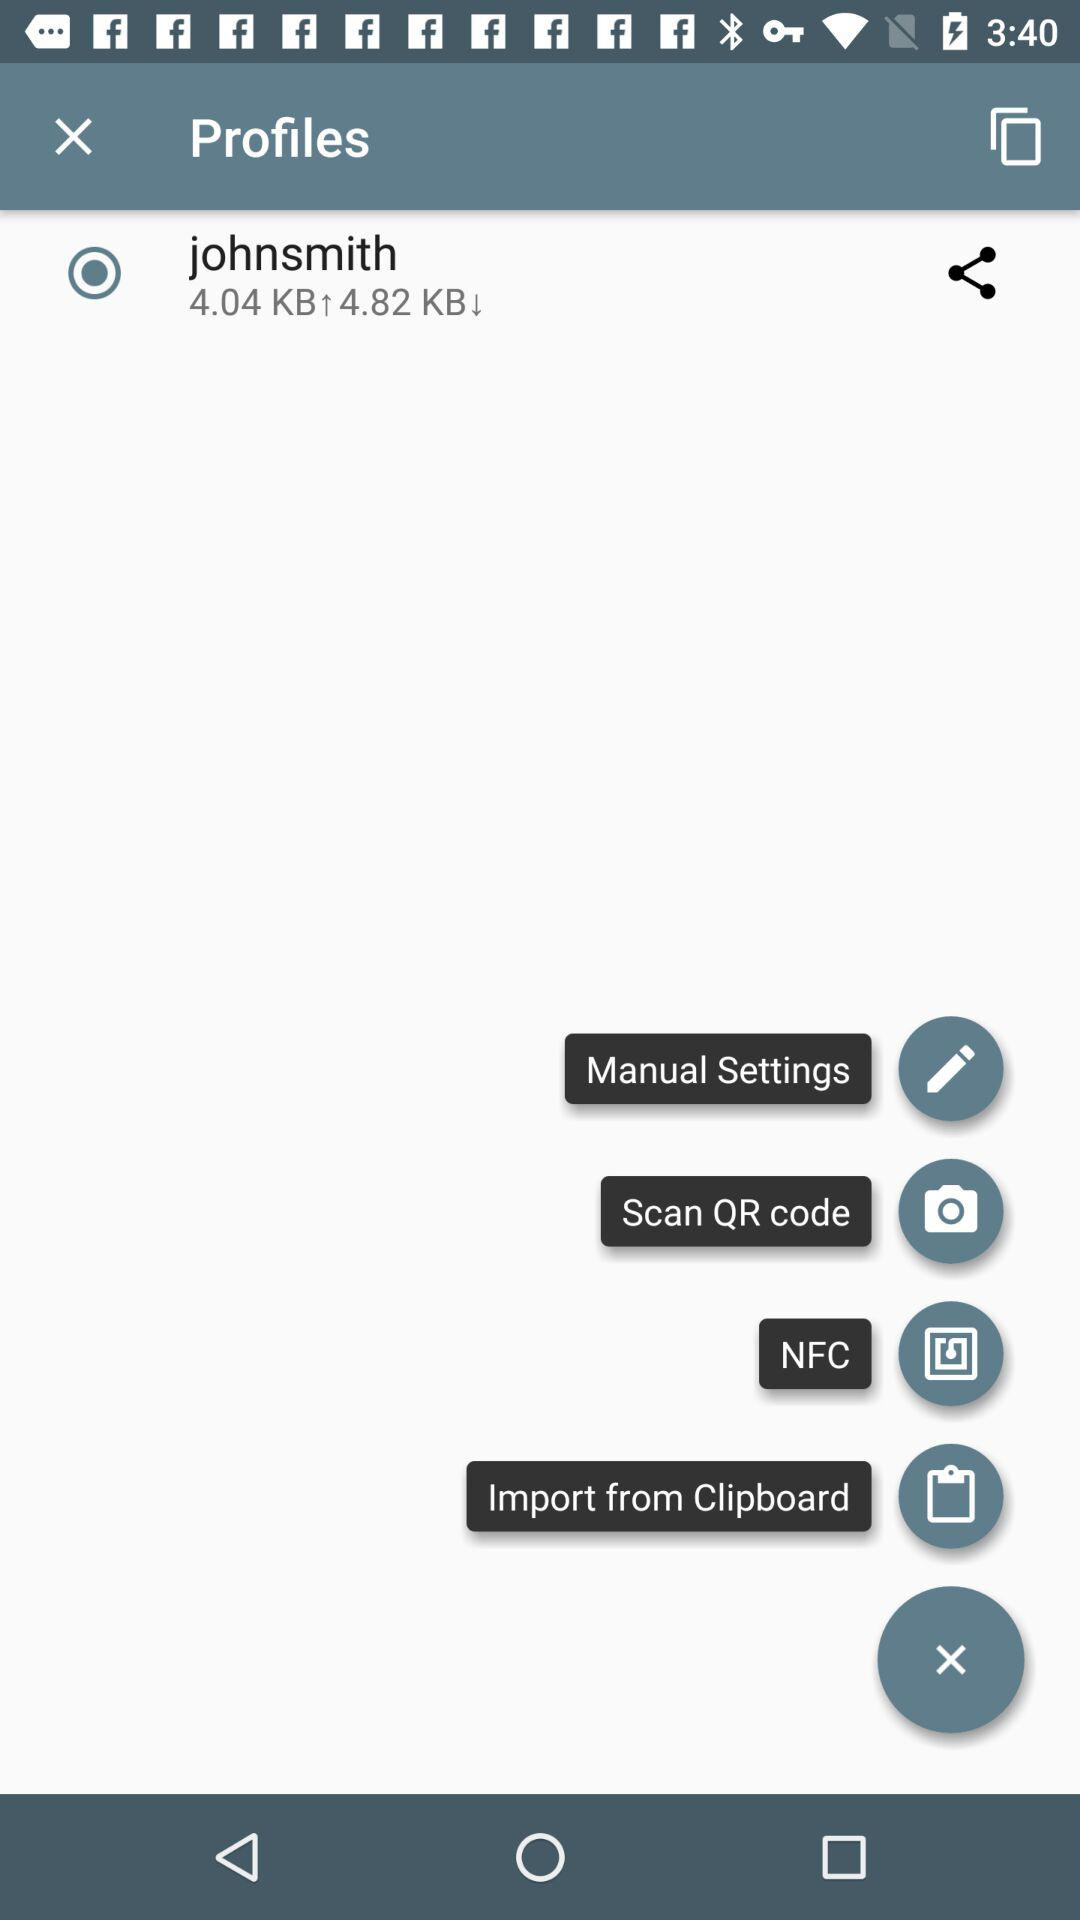What is the download speed? The download speed is 4.82 KB. 